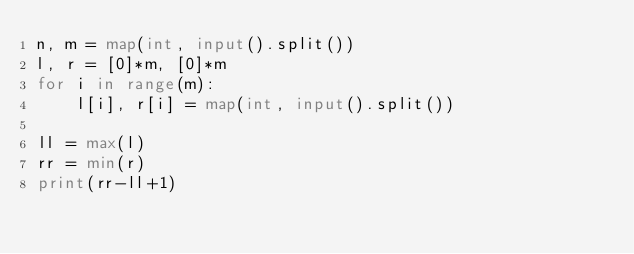<code> <loc_0><loc_0><loc_500><loc_500><_Python_>n, m = map(int, input().split())
l, r = [0]*m, [0]*m
for i in range(m):
    l[i], r[i] = map(int, input().split())

ll = max(l)
rr = min(r)
print(rr-ll+1)</code> 